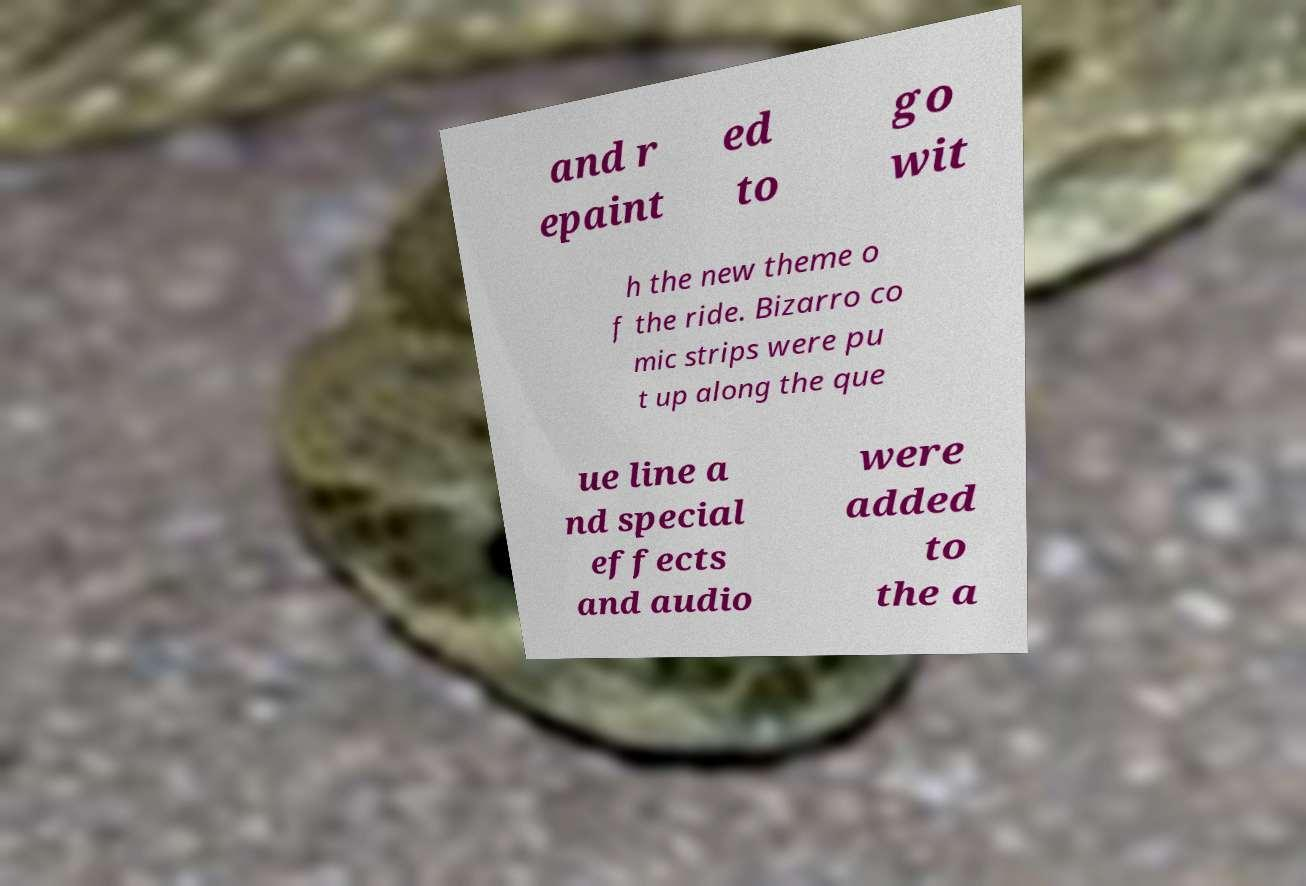For documentation purposes, I need the text within this image transcribed. Could you provide that? and r epaint ed to go wit h the new theme o f the ride. Bizarro co mic strips were pu t up along the que ue line a nd special effects and audio were added to the a 